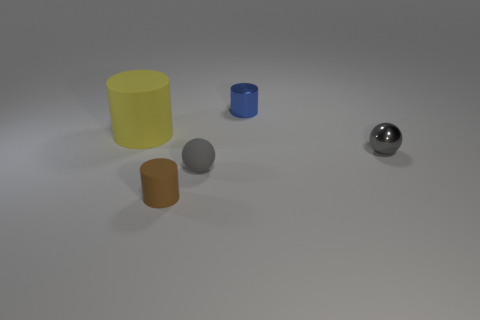Subtract all tiny shiny cylinders. How many cylinders are left? 2 Add 2 yellow metal cylinders. How many objects exist? 7 Subtract all blue cylinders. How many cylinders are left? 2 Subtract 1 cylinders. How many cylinders are left? 2 Subtract all cylinders. How many objects are left? 2 Subtract all yellow spheres. Subtract all green cylinders. How many spheres are left? 2 Subtract all small brown rubber objects. Subtract all green matte cylinders. How many objects are left? 4 Add 5 tiny blue objects. How many tiny blue objects are left? 6 Add 5 small brown matte cylinders. How many small brown matte cylinders exist? 6 Subtract 0 blue cubes. How many objects are left? 5 